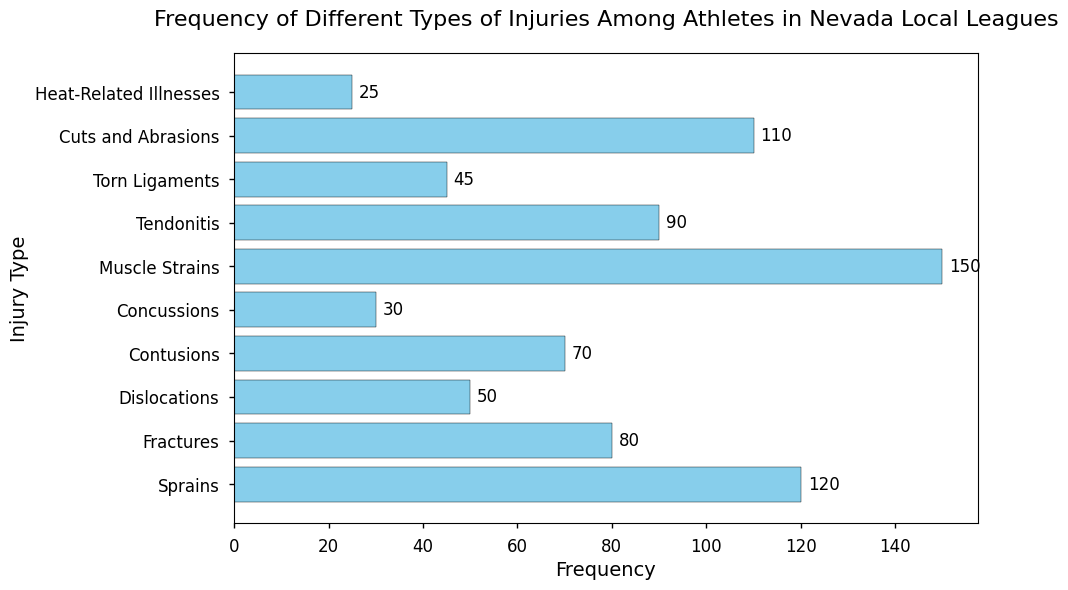What is the most frequent type of injury? The most frequent type of injury can be identified by looking at the longest bar in the histogram. Here, the "Muscle Strains" bar is the longest with a frequency of 150.
Answer: Muscle Strains Which injury type occurs more frequently: Fractures or Dislocations? By comparing the lengths of the "Fractures" and "Dislocations" bars, we see that "Fractures" (80) is longer than "Dislocations" (50).
Answer: Fractures What is the total frequency of "Sprains" and "Contusions"? Adding the frequencies of "Sprains" (120) and "Contusions" (70) gives us 120 + 70 = 190.
Answer: 190 Which injury type has the lowest frequency? The injury type with the shortest bar represents the lowest frequency. "Heat-Related Illnesses" has the shortest bar with a frequency of 25.
Answer: Heat-Related Illnesses How much greater is the frequency of "Tendonitis" compared to "Cuts and Abrasions"? The frequency of "Tendonitis" is 90, and the frequency of "Cuts and Abrasions" is 110. The difference is 110 - 90 = 20.
Answer: 20 What is the difference in frequency between the most and least common injuries? The most frequent injury is "Muscle Strains" with a frequency of 150, and the least frequent is "Heat-Related Illnesses" with a frequency of 25. The difference is 150 - 25 = 125.
Answer: 125 Are there more "Sprains" or "Tendonitis" injuries reported? Comparing the bars for "Sprains" (120) and "Tendonitis" (90), we see that "Sprains" are more frequent.
Answer: Sprains How many types of injuries have a frequency greater than 100? Injuries with a frequency greater than 100 are "Sprains" (120), "Muscle Strains" (150), and "Cuts and Abrasions" (110). There are 3 such injury types.
Answer: 3 Which injury type's frequency is closest to the average frequency of all injuries? First, we calculate the average frequency by summing all frequencies and dividing by the number of injury types. The sum of frequencies is 120 + 80 + 50 + 70 + 30 + 150 + 90 + 45 + 110 + 25 = 770. The average is 770 / 10 = 77. The frequency closest to 77 is "Fractures" with a frequency of 80.
Answer: Fractures Which two injury types combined have the same frequency as "Muscle Strains"? "Muscle Strains" has a frequency of 150. We look for two injury types whose frequencies sum to 150. "Cuts and Abrasions" (110) combined with "Heat-Related Illnesses" (25) gives 110 + 25 = 135, which is closest but not equal. Finally, combining "Fractures" (80) and "Sprains" (120) will give us 80 + 70 = 150.
Answer: Fractures and Sprains 